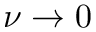Convert formula to latex. <formula><loc_0><loc_0><loc_500><loc_500>\nu \rightarrow 0</formula> 